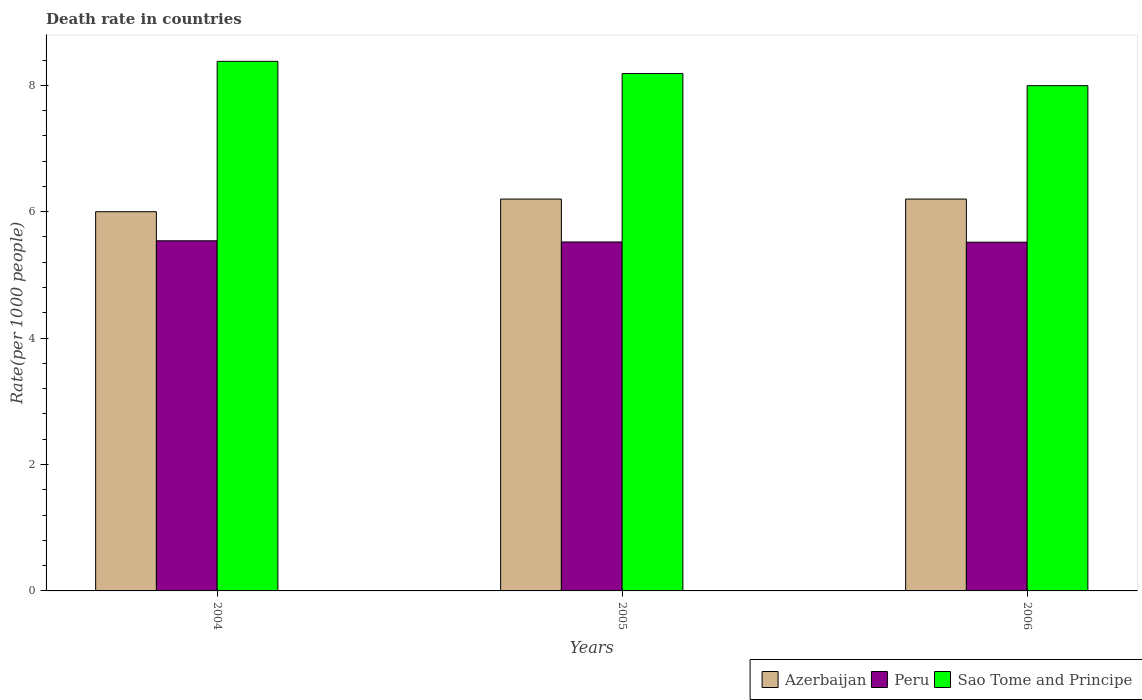How many different coloured bars are there?
Offer a terse response. 3. How many groups of bars are there?
Your response must be concise. 3. Are the number of bars per tick equal to the number of legend labels?
Make the answer very short. Yes. Are the number of bars on each tick of the X-axis equal?
Provide a short and direct response. Yes. How many bars are there on the 2nd tick from the right?
Your answer should be very brief. 3. What is the label of the 2nd group of bars from the left?
Your response must be concise. 2005. Across all years, what is the minimum death rate in Peru?
Make the answer very short. 5.52. In which year was the death rate in Azerbaijan maximum?
Offer a terse response. 2005. What is the total death rate in Peru in the graph?
Your answer should be compact. 16.58. What is the difference between the death rate in Peru in 2004 and that in 2005?
Your answer should be compact. 0.02. What is the difference between the death rate in Peru in 2006 and the death rate in Sao Tome and Principe in 2004?
Give a very brief answer. -2.86. What is the average death rate in Peru per year?
Offer a terse response. 5.53. In the year 2006, what is the difference between the death rate in Azerbaijan and death rate in Peru?
Give a very brief answer. 0.68. What is the ratio of the death rate in Peru in 2005 to that in 2006?
Ensure brevity in your answer.  1. Is the difference between the death rate in Azerbaijan in 2005 and 2006 greater than the difference between the death rate in Peru in 2005 and 2006?
Offer a terse response. No. What is the difference between the highest and the second highest death rate in Azerbaijan?
Your response must be concise. 0. What is the difference between the highest and the lowest death rate in Peru?
Offer a terse response. 0.02. Is the sum of the death rate in Peru in 2004 and 2006 greater than the maximum death rate in Sao Tome and Principe across all years?
Keep it short and to the point. Yes. What does the 1st bar from the left in 2006 represents?
Give a very brief answer. Azerbaijan. What does the 3rd bar from the right in 2005 represents?
Provide a short and direct response. Azerbaijan. Is it the case that in every year, the sum of the death rate in Azerbaijan and death rate in Sao Tome and Principe is greater than the death rate in Peru?
Make the answer very short. Yes. How many bars are there?
Make the answer very short. 9. Are the values on the major ticks of Y-axis written in scientific E-notation?
Offer a terse response. No. Does the graph contain any zero values?
Offer a very short reply. No. How are the legend labels stacked?
Offer a terse response. Horizontal. What is the title of the graph?
Your answer should be compact. Death rate in countries. Does "Sint Maarten (Dutch part)" appear as one of the legend labels in the graph?
Offer a terse response. No. What is the label or title of the X-axis?
Give a very brief answer. Years. What is the label or title of the Y-axis?
Ensure brevity in your answer.  Rate(per 1000 people). What is the Rate(per 1000 people) in Azerbaijan in 2004?
Provide a succinct answer. 6. What is the Rate(per 1000 people) of Peru in 2004?
Make the answer very short. 5.54. What is the Rate(per 1000 people) in Sao Tome and Principe in 2004?
Provide a short and direct response. 8.38. What is the Rate(per 1000 people) in Azerbaijan in 2005?
Ensure brevity in your answer.  6.2. What is the Rate(per 1000 people) in Peru in 2005?
Your response must be concise. 5.52. What is the Rate(per 1000 people) of Sao Tome and Principe in 2005?
Provide a short and direct response. 8.19. What is the Rate(per 1000 people) in Azerbaijan in 2006?
Make the answer very short. 6.2. What is the Rate(per 1000 people) of Peru in 2006?
Your answer should be very brief. 5.52. What is the Rate(per 1000 people) of Sao Tome and Principe in 2006?
Your answer should be compact. 7.99. Across all years, what is the maximum Rate(per 1000 people) in Peru?
Your answer should be very brief. 5.54. Across all years, what is the maximum Rate(per 1000 people) in Sao Tome and Principe?
Provide a short and direct response. 8.38. Across all years, what is the minimum Rate(per 1000 people) of Azerbaijan?
Ensure brevity in your answer.  6. Across all years, what is the minimum Rate(per 1000 people) in Peru?
Ensure brevity in your answer.  5.52. Across all years, what is the minimum Rate(per 1000 people) in Sao Tome and Principe?
Offer a very short reply. 7.99. What is the total Rate(per 1000 people) of Peru in the graph?
Your answer should be compact. 16.58. What is the total Rate(per 1000 people) in Sao Tome and Principe in the graph?
Provide a short and direct response. 24.56. What is the difference between the Rate(per 1000 people) in Peru in 2004 and that in 2005?
Your response must be concise. 0.02. What is the difference between the Rate(per 1000 people) in Sao Tome and Principe in 2004 and that in 2005?
Keep it short and to the point. 0.19. What is the difference between the Rate(per 1000 people) of Peru in 2004 and that in 2006?
Your answer should be compact. 0.02. What is the difference between the Rate(per 1000 people) of Sao Tome and Principe in 2004 and that in 2006?
Give a very brief answer. 0.39. What is the difference between the Rate(per 1000 people) in Azerbaijan in 2005 and that in 2006?
Provide a short and direct response. 0. What is the difference between the Rate(per 1000 people) in Peru in 2005 and that in 2006?
Your answer should be compact. 0. What is the difference between the Rate(per 1000 people) of Sao Tome and Principe in 2005 and that in 2006?
Ensure brevity in your answer.  0.19. What is the difference between the Rate(per 1000 people) of Azerbaijan in 2004 and the Rate(per 1000 people) of Peru in 2005?
Provide a short and direct response. 0.48. What is the difference between the Rate(per 1000 people) of Azerbaijan in 2004 and the Rate(per 1000 people) of Sao Tome and Principe in 2005?
Provide a short and direct response. -2.19. What is the difference between the Rate(per 1000 people) of Peru in 2004 and the Rate(per 1000 people) of Sao Tome and Principe in 2005?
Your response must be concise. -2.65. What is the difference between the Rate(per 1000 people) of Azerbaijan in 2004 and the Rate(per 1000 people) of Peru in 2006?
Your answer should be compact. 0.48. What is the difference between the Rate(per 1000 people) in Azerbaijan in 2004 and the Rate(per 1000 people) in Sao Tome and Principe in 2006?
Your response must be concise. -1.99. What is the difference between the Rate(per 1000 people) in Peru in 2004 and the Rate(per 1000 people) in Sao Tome and Principe in 2006?
Your answer should be very brief. -2.45. What is the difference between the Rate(per 1000 people) of Azerbaijan in 2005 and the Rate(per 1000 people) of Peru in 2006?
Offer a very short reply. 0.68. What is the difference between the Rate(per 1000 people) in Azerbaijan in 2005 and the Rate(per 1000 people) in Sao Tome and Principe in 2006?
Your answer should be compact. -1.79. What is the difference between the Rate(per 1000 people) of Peru in 2005 and the Rate(per 1000 people) of Sao Tome and Principe in 2006?
Ensure brevity in your answer.  -2.47. What is the average Rate(per 1000 people) of Azerbaijan per year?
Ensure brevity in your answer.  6.13. What is the average Rate(per 1000 people) of Peru per year?
Offer a very short reply. 5.53. What is the average Rate(per 1000 people) of Sao Tome and Principe per year?
Your answer should be compact. 8.19. In the year 2004, what is the difference between the Rate(per 1000 people) of Azerbaijan and Rate(per 1000 people) of Peru?
Your answer should be very brief. 0.46. In the year 2004, what is the difference between the Rate(per 1000 people) of Azerbaijan and Rate(per 1000 people) of Sao Tome and Principe?
Offer a terse response. -2.38. In the year 2004, what is the difference between the Rate(per 1000 people) in Peru and Rate(per 1000 people) in Sao Tome and Principe?
Provide a short and direct response. -2.84. In the year 2005, what is the difference between the Rate(per 1000 people) of Azerbaijan and Rate(per 1000 people) of Peru?
Ensure brevity in your answer.  0.68. In the year 2005, what is the difference between the Rate(per 1000 people) of Azerbaijan and Rate(per 1000 people) of Sao Tome and Principe?
Provide a succinct answer. -1.99. In the year 2005, what is the difference between the Rate(per 1000 people) of Peru and Rate(per 1000 people) of Sao Tome and Principe?
Your answer should be very brief. -2.67. In the year 2006, what is the difference between the Rate(per 1000 people) in Azerbaijan and Rate(per 1000 people) in Peru?
Make the answer very short. 0.68. In the year 2006, what is the difference between the Rate(per 1000 people) of Azerbaijan and Rate(per 1000 people) of Sao Tome and Principe?
Offer a terse response. -1.79. In the year 2006, what is the difference between the Rate(per 1000 people) of Peru and Rate(per 1000 people) of Sao Tome and Principe?
Your response must be concise. -2.48. What is the ratio of the Rate(per 1000 people) of Azerbaijan in 2004 to that in 2005?
Ensure brevity in your answer.  0.97. What is the ratio of the Rate(per 1000 people) in Sao Tome and Principe in 2004 to that in 2005?
Keep it short and to the point. 1.02. What is the ratio of the Rate(per 1000 people) of Azerbaijan in 2004 to that in 2006?
Ensure brevity in your answer.  0.97. What is the ratio of the Rate(per 1000 people) in Sao Tome and Principe in 2004 to that in 2006?
Your answer should be compact. 1.05. What is the ratio of the Rate(per 1000 people) in Sao Tome and Principe in 2005 to that in 2006?
Offer a very short reply. 1.02. What is the difference between the highest and the second highest Rate(per 1000 people) in Peru?
Make the answer very short. 0.02. What is the difference between the highest and the second highest Rate(per 1000 people) of Sao Tome and Principe?
Ensure brevity in your answer.  0.19. What is the difference between the highest and the lowest Rate(per 1000 people) in Peru?
Offer a very short reply. 0.02. What is the difference between the highest and the lowest Rate(per 1000 people) in Sao Tome and Principe?
Offer a very short reply. 0.39. 